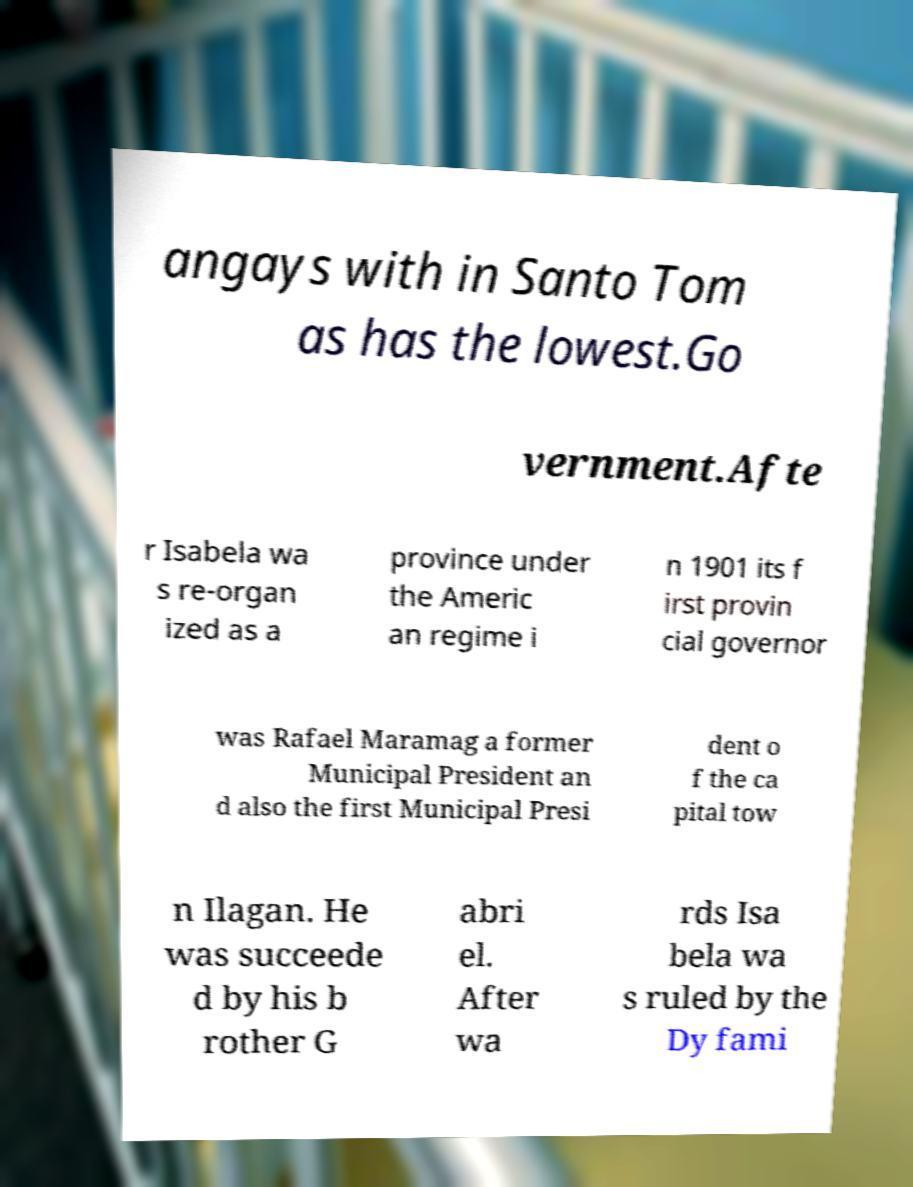There's text embedded in this image that I need extracted. Can you transcribe it verbatim? angays with in Santo Tom as has the lowest.Go vernment.Afte r Isabela wa s re-organ ized as a province under the Americ an regime i n 1901 its f irst provin cial governor was Rafael Maramag a former Municipal President an d also the first Municipal Presi dent o f the ca pital tow n Ilagan. He was succeede d by his b rother G abri el. After wa rds Isa bela wa s ruled by the Dy fami 